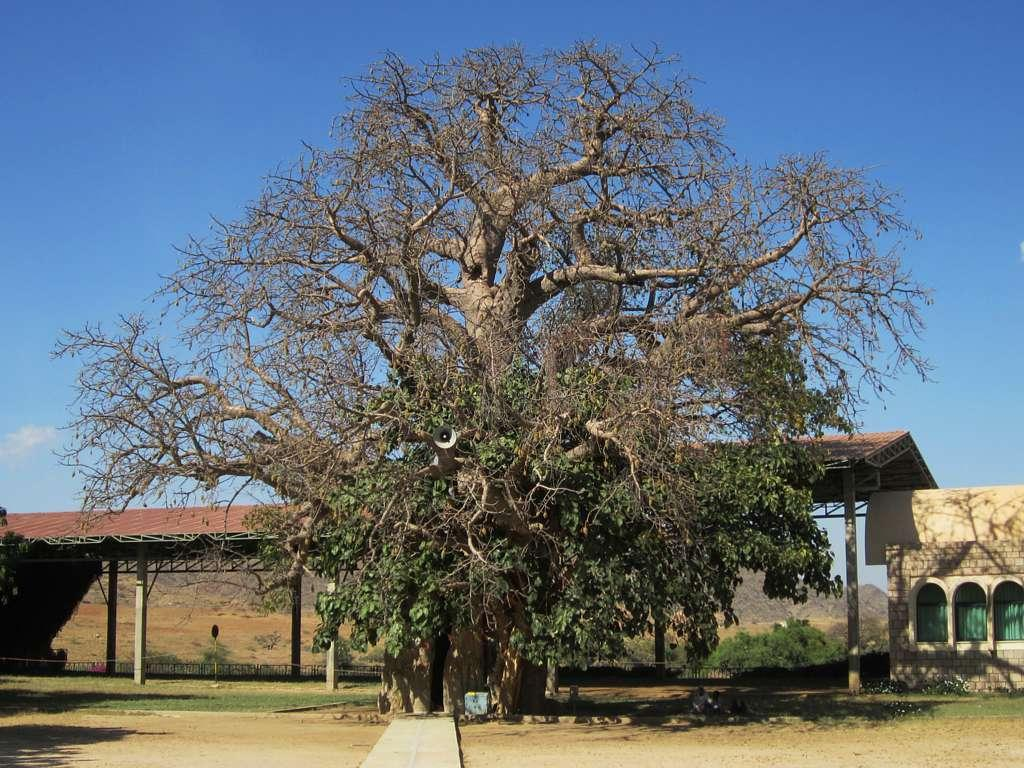What type of structure is present on the left side of the image? There is a shed in the image. What other structure can be seen in the image? There is a house in the image. How many windows are on the house? The house has three windows. What type of natural element is present in the image? There is a tree in the image. Where is the tree located in relation to the other structures? The tree is on the floor (likely meaning the ground) in the image. How does the kitten compare to the size of the shed in the image? There is no kitten present in the image. 